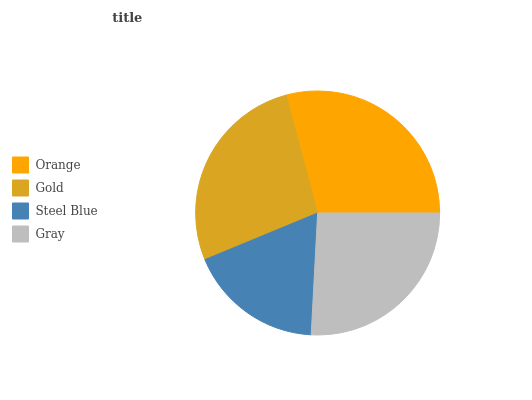Is Steel Blue the minimum?
Answer yes or no. Yes. Is Orange the maximum?
Answer yes or no. Yes. Is Gold the minimum?
Answer yes or no. No. Is Gold the maximum?
Answer yes or no. No. Is Orange greater than Gold?
Answer yes or no. Yes. Is Gold less than Orange?
Answer yes or no. Yes. Is Gold greater than Orange?
Answer yes or no. No. Is Orange less than Gold?
Answer yes or no. No. Is Gold the high median?
Answer yes or no. Yes. Is Gray the low median?
Answer yes or no. Yes. Is Steel Blue the high median?
Answer yes or no. No. Is Steel Blue the low median?
Answer yes or no. No. 